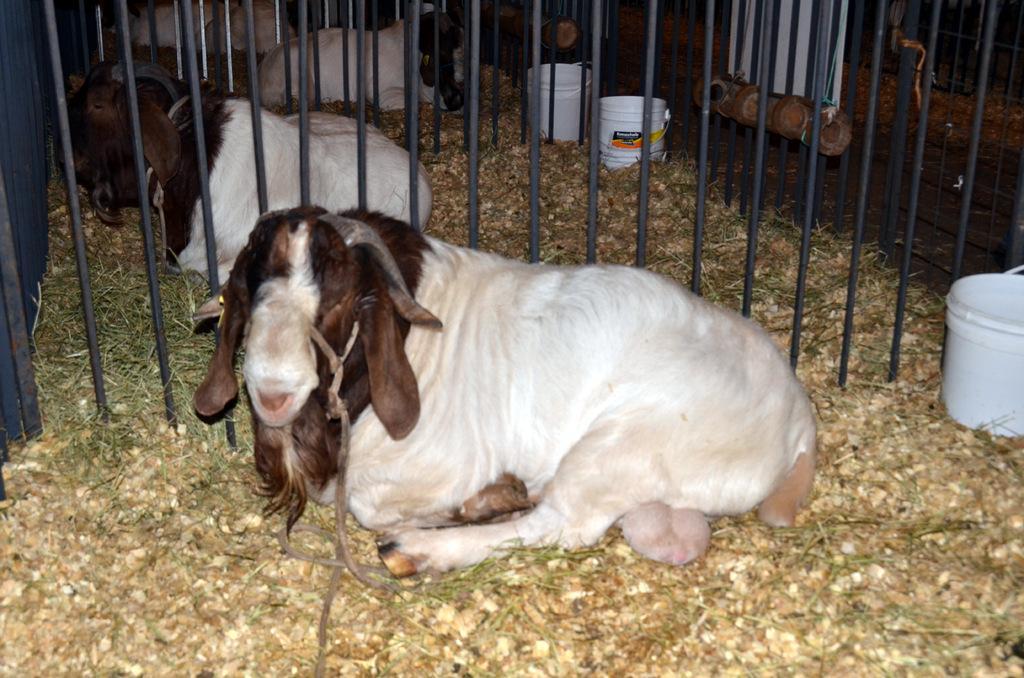Describe this image in one or two sentences. In this image I can see few animals which are in brown and white color. I can see few buckets,fencing and dry grass. 